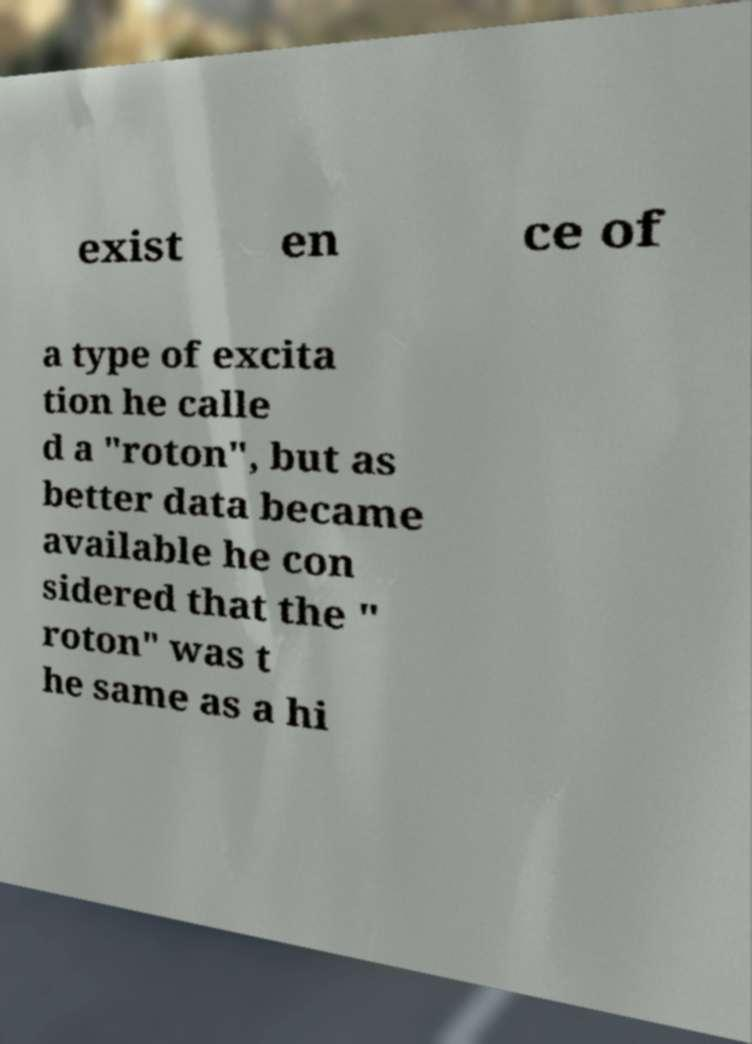Can you accurately transcribe the text from the provided image for me? exist en ce of a type of excita tion he calle d a "roton", but as better data became available he con sidered that the " roton" was t he same as a hi 